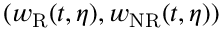<formula> <loc_0><loc_0><loc_500><loc_500>( w _ { R } ( t , \eta ) , w _ { N R } ( t , \eta ) )</formula> 